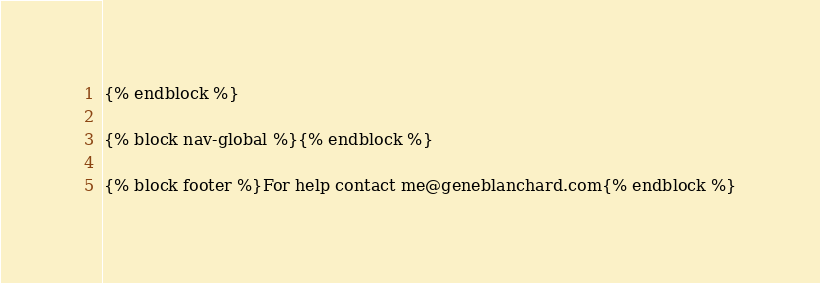<code> <loc_0><loc_0><loc_500><loc_500><_HTML_>{% endblock %}

{% block nav-global %}{% endblock %}

{% block footer %}For help contact me@geneblanchard.com{% endblock %}
</code> 